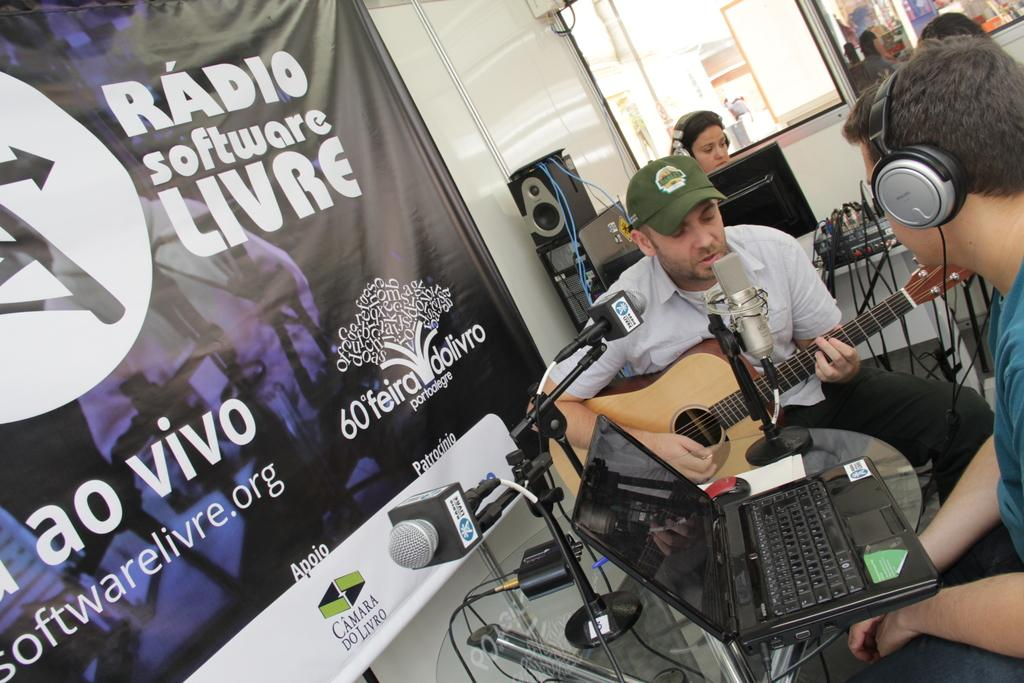What is the man in the image doing? The man is playing a guitar in the image. What other objects can be seen in the image besides the man and the guitar? There is a laptop, musical instruments, a banner, a wall, and a window in the image. What might the man be using the laptop for? It is not clear from the image what the man is using the laptop for, but it could be related to music or performance. What is the purpose of the banner in the image? The purpose of the banner in the image is not clear, but it could be for advertising or decoration. What type of vegetable is the man holding in the image? There is no vegetable present in the image; the man is playing a guitar. What is the man thinking about while playing the guitar in the image? It is not possible to determine what the man is thinking about from the image alone. 